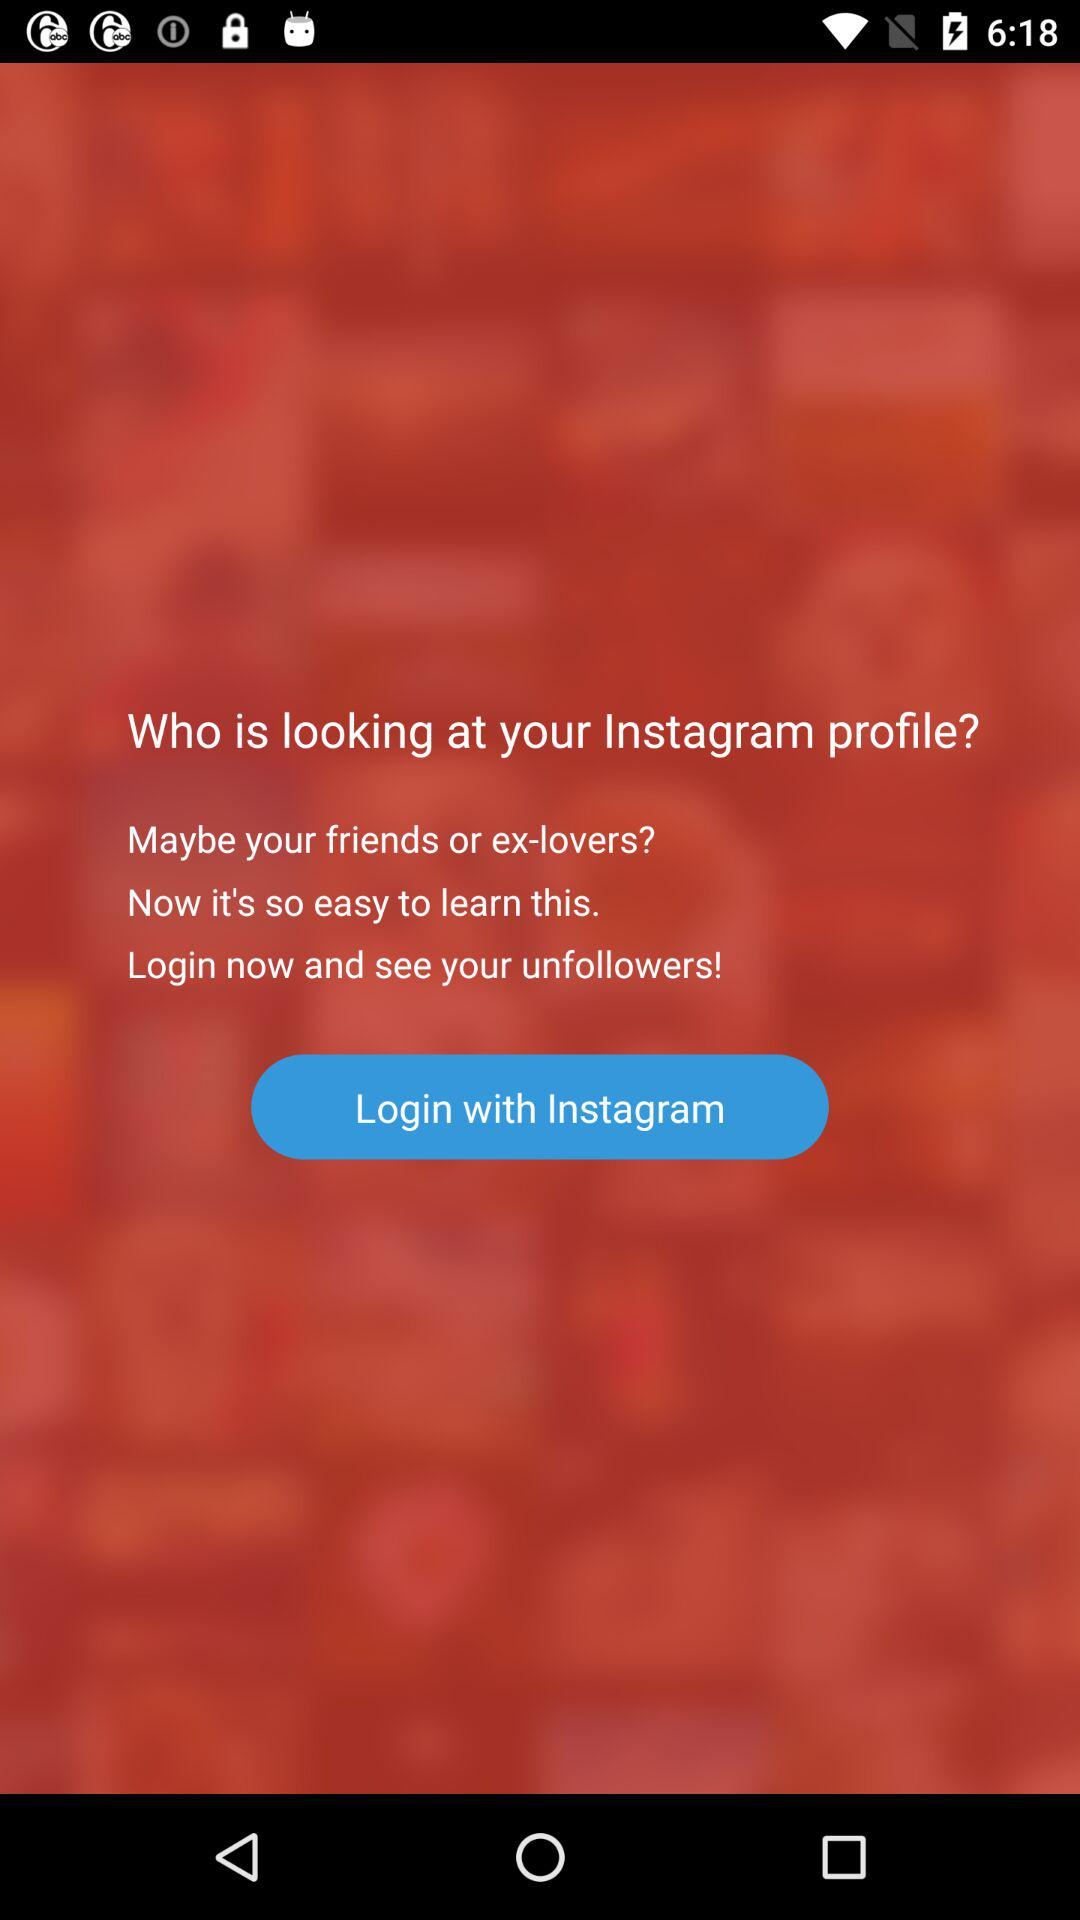What application is used for login? The application is "Instagram". 